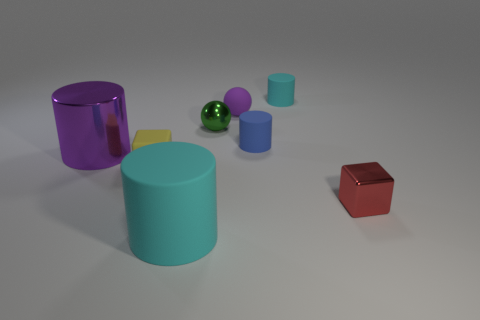Subtract all big cyan matte cylinders. How many cylinders are left? 3 Subtract all cyan balls. How many cyan cylinders are left? 2 Subtract 1 cylinders. How many cylinders are left? 3 Subtract all purple cylinders. How many cylinders are left? 3 Add 1 yellow rubber things. How many objects exist? 9 Subtract all brown cylinders. Subtract all purple spheres. How many cylinders are left? 4 Subtract all cubes. How many objects are left? 6 Add 4 big metallic cubes. How many big metallic cubes exist? 4 Subtract 1 cyan cylinders. How many objects are left? 7 Subtract all red objects. Subtract all small red metallic balls. How many objects are left? 7 